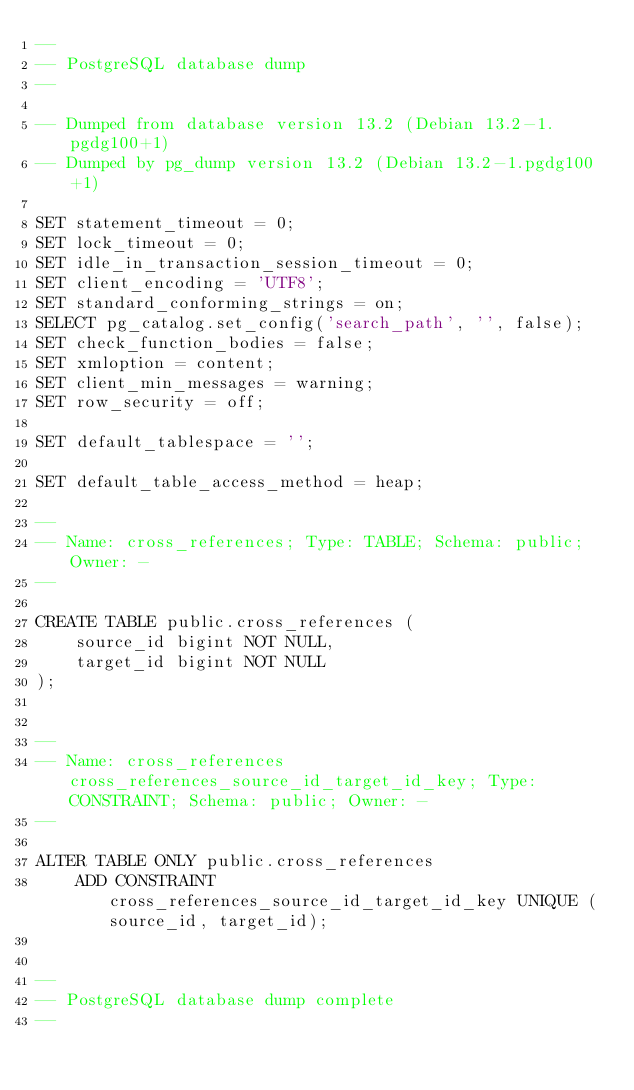<code> <loc_0><loc_0><loc_500><loc_500><_SQL_>--
-- PostgreSQL database dump
--

-- Dumped from database version 13.2 (Debian 13.2-1.pgdg100+1)
-- Dumped by pg_dump version 13.2 (Debian 13.2-1.pgdg100+1)

SET statement_timeout = 0;
SET lock_timeout = 0;
SET idle_in_transaction_session_timeout = 0;
SET client_encoding = 'UTF8';
SET standard_conforming_strings = on;
SELECT pg_catalog.set_config('search_path', '', false);
SET check_function_bodies = false;
SET xmloption = content;
SET client_min_messages = warning;
SET row_security = off;

SET default_tablespace = '';

SET default_table_access_method = heap;

--
-- Name: cross_references; Type: TABLE; Schema: public; Owner: -
--

CREATE TABLE public.cross_references (
    source_id bigint NOT NULL,
    target_id bigint NOT NULL
);


--
-- Name: cross_references cross_references_source_id_target_id_key; Type: CONSTRAINT; Schema: public; Owner: -
--

ALTER TABLE ONLY public.cross_references
    ADD CONSTRAINT cross_references_source_id_target_id_key UNIQUE (source_id, target_id);


--
-- PostgreSQL database dump complete
--
</code> 